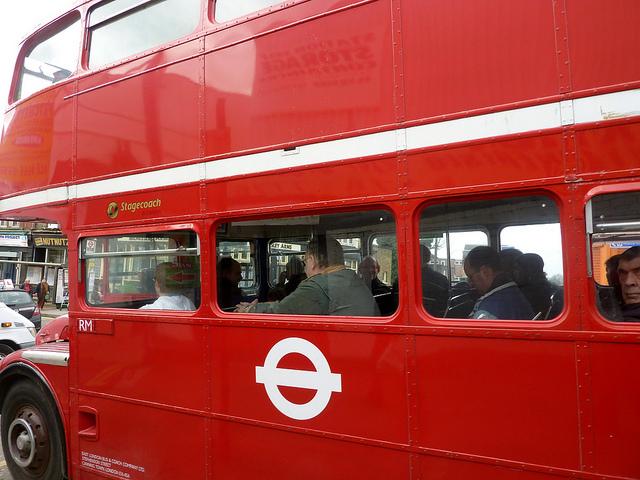What color is the bus?
Write a very short answer. Red. What is the white symbol on the red bus?
Short answer required. Circle. Is someone on the bus looking towards the camera?
Quick response, please. Yes. 